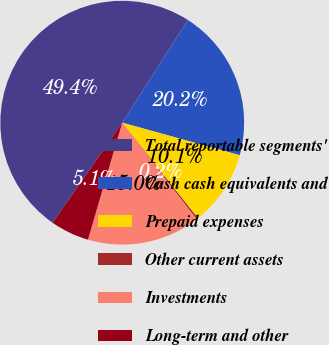Convert chart to OTSL. <chart><loc_0><loc_0><loc_500><loc_500><pie_chart><fcel>Total reportable segments'<fcel>Cash cash equivalents and<fcel>Prepaid expenses<fcel>Other current assets<fcel>Investments<fcel>Long-term and other<nl><fcel>49.37%<fcel>20.24%<fcel>10.05%<fcel>0.22%<fcel>14.97%<fcel>5.14%<nl></chart> 